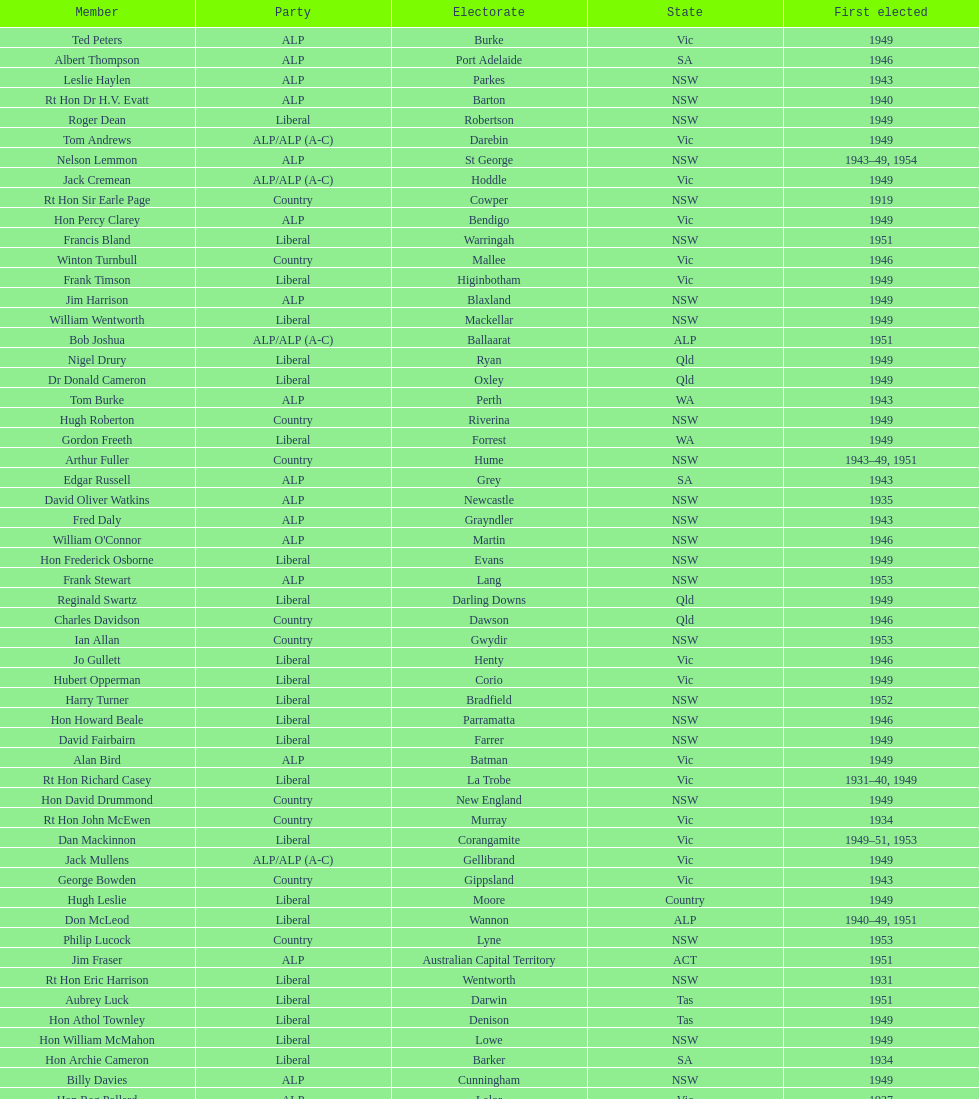When was joe clark first elected? 1934. 